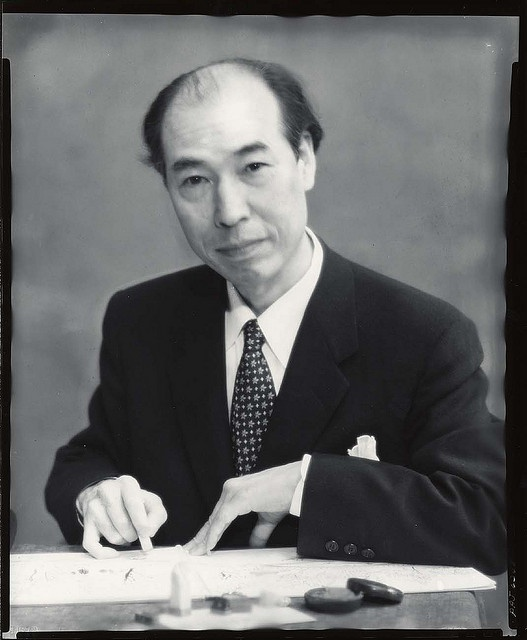Describe the objects in this image and their specific colors. I can see people in black, lightgray, darkgray, and gray tones and tie in black, gray, and darkgray tones in this image. 